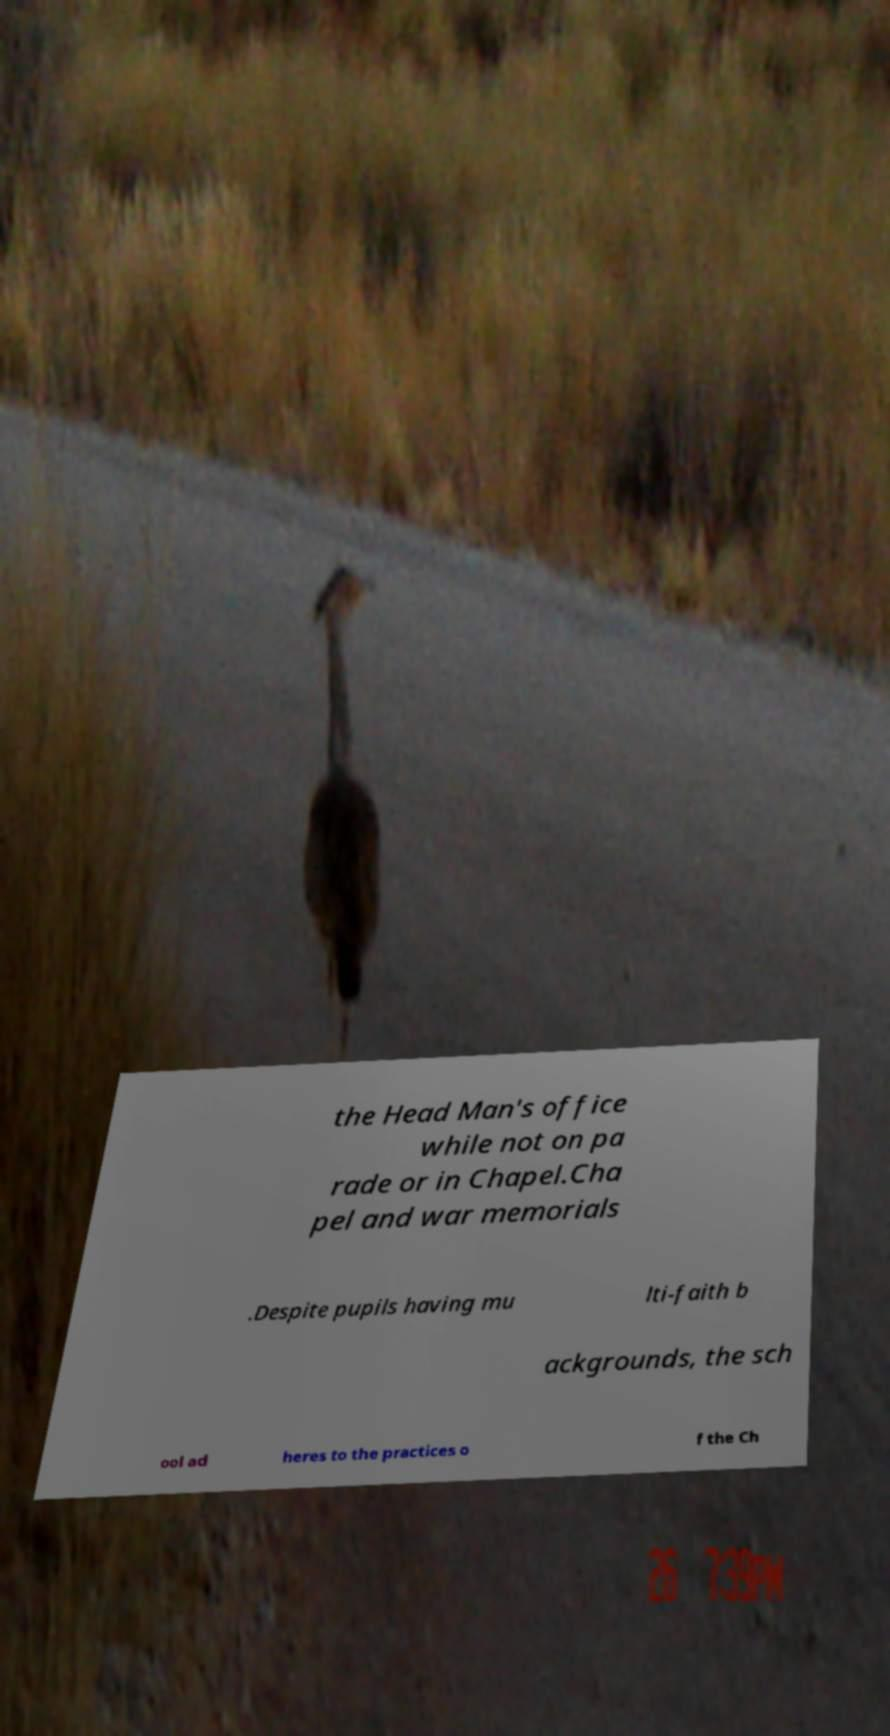Please identify and transcribe the text found in this image. the Head Man's office while not on pa rade or in Chapel.Cha pel and war memorials .Despite pupils having mu lti-faith b ackgrounds, the sch ool ad heres to the practices o f the Ch 